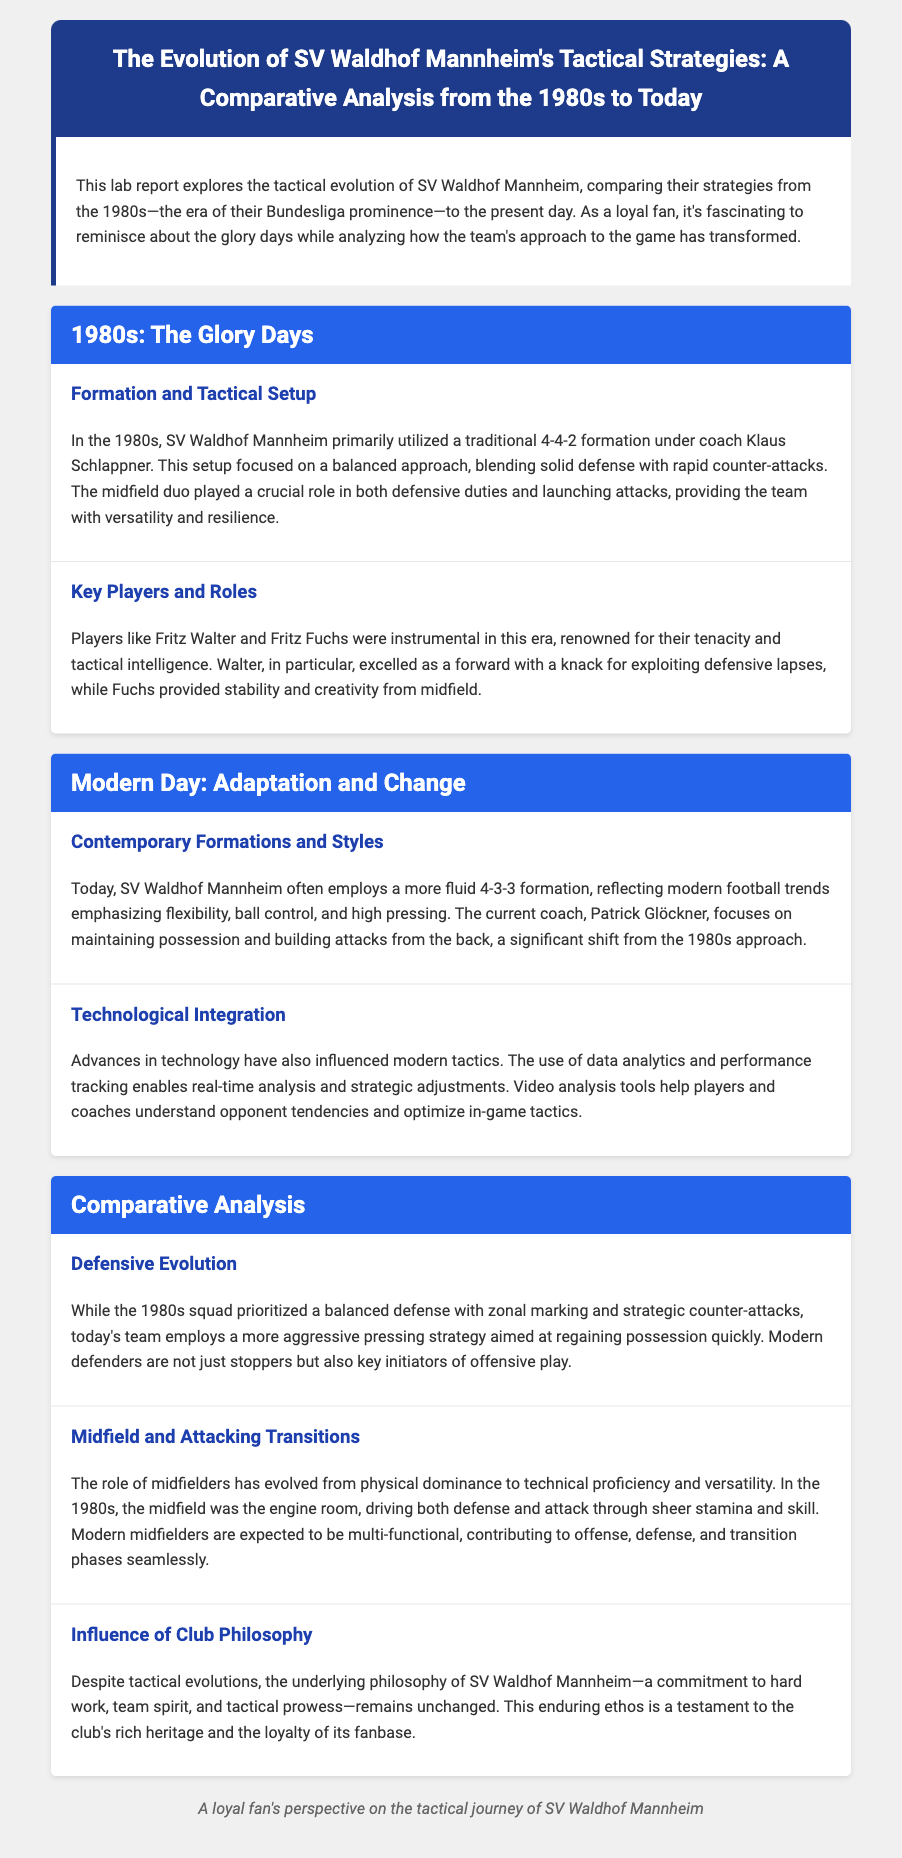What formation was primarily used in the 1980s? The document states that in the 1980s, SV Waldhof Mannheim primarily utilized a traditional 4-4-2 formation.
Answer: 4-4-2 Who was the coach during the 1980s? The document mentions Klaus Schlappner as the coach during the 1980s.
Answer: Klaus Schlappner What is the current formation used by SV Waldhof Mannheim? According to the document, today the team often employs a more fluid 4-3-3 formation.
Answer: 4-3-3 What is a key change in tacticals from the 1980s to today? The document explains that modern defenders are not just stoppers but also key initiators of offensive play, which contrasts with previous strategies.
Answer: Offensive play initiators Which key player is noted for his forward role in the 1980s? The report highlights Fritz Walter for his role as a forward in the 1980s.
Answer: Fritz Walter What influences modern tactics according to the report? The document indicates that advances in technology influence modern tactics, particularly data analytics and performance tracking.
Answer: Technology How has the role of midfielders changed? The report mentions that the role of midfielders has evolved from physical dominance to technical proficiency and versatility.
Answer: Technical proficiency What remains unchanged in SV Waldhof Mannheim's philosophy? The document states that the commitment to hard work, team spirit, and tactical prowess remains unchanged.
Answer: Commitment to hard work What was a characteristic of the 1980s defensive strategy? The document describes the 1980s squad's defense as focused on zonal marking and strategic counter-attacks.
Answer: Zonal marking and counter-attacks 